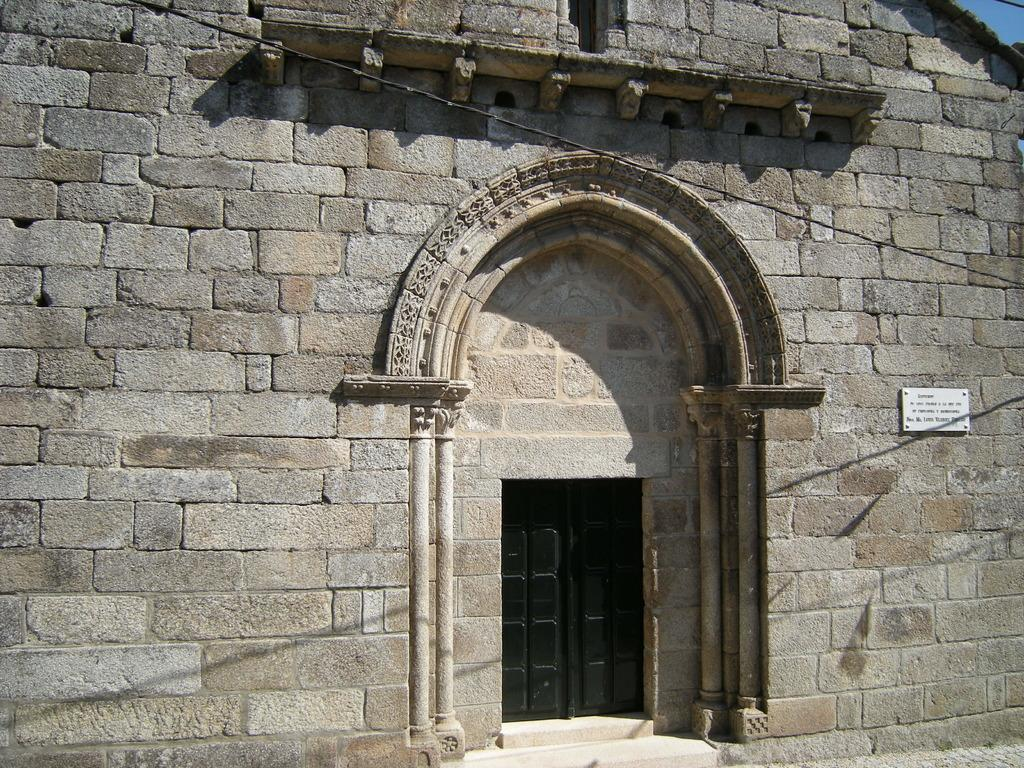What type of structure is visible in the image? There is a building in the image. What is attached to the building in the image? There is a wire in the image. What feature of the building allows access to the interior? There are doors in the image. How can one reach the entrance of the building? There are steps in the image. What is displayed on the wall of the building? There is a name board on the wall in the image. How many needles are used to fold the steps in the image? There are no needles or folding involved in the steps in the image; they are a solid structure for people to walk on. 